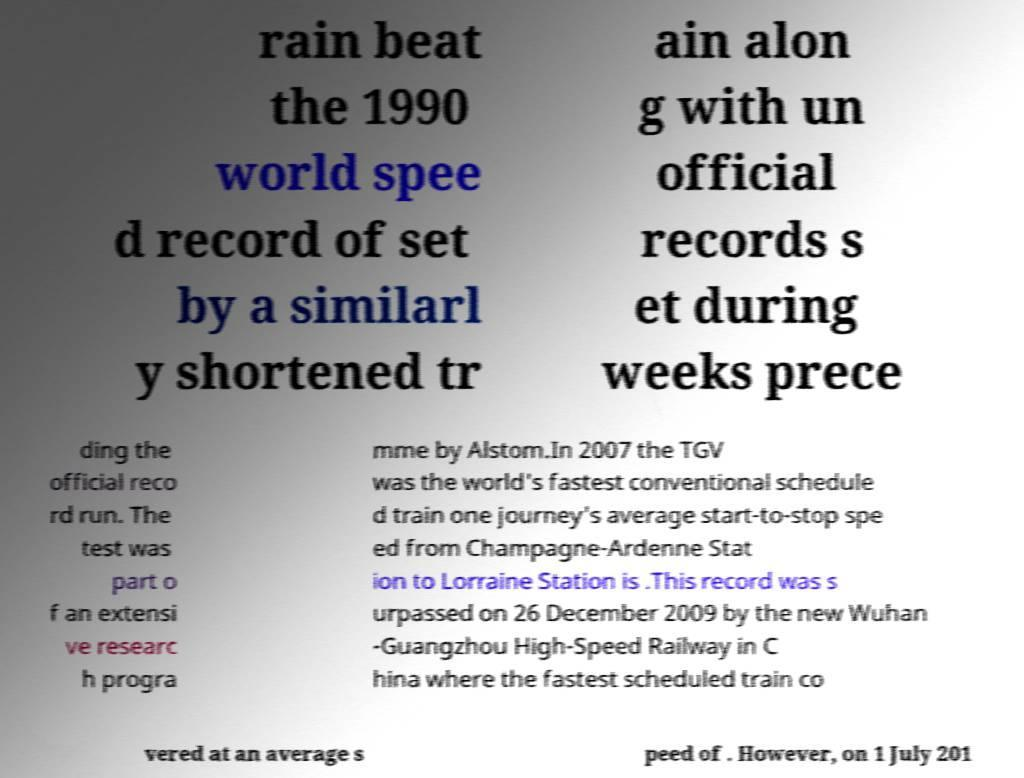Could you assist in decoding the text presented in this image and type it out clearly? rain beat the 1990 world spee d record of set by a similarl y shortened tr ain alon g with un official records s et during weeks prece ding the official reco rd run. The test was part o f an extensi ve researc h progra mme by Alstom.In 2007 the TGV was the world's fastest conventional schedule d train one journey's average start-to-stop spe ed from Champagne-Ardenne Stat ion to Lorraine Station is .This record was s urpassed on 26 December 2009 by the new Wuhan -Guangzhou High-Speed Railway in C hina where the fastest scheduled train co vered at an average s peed of . However, on 1 July 201 